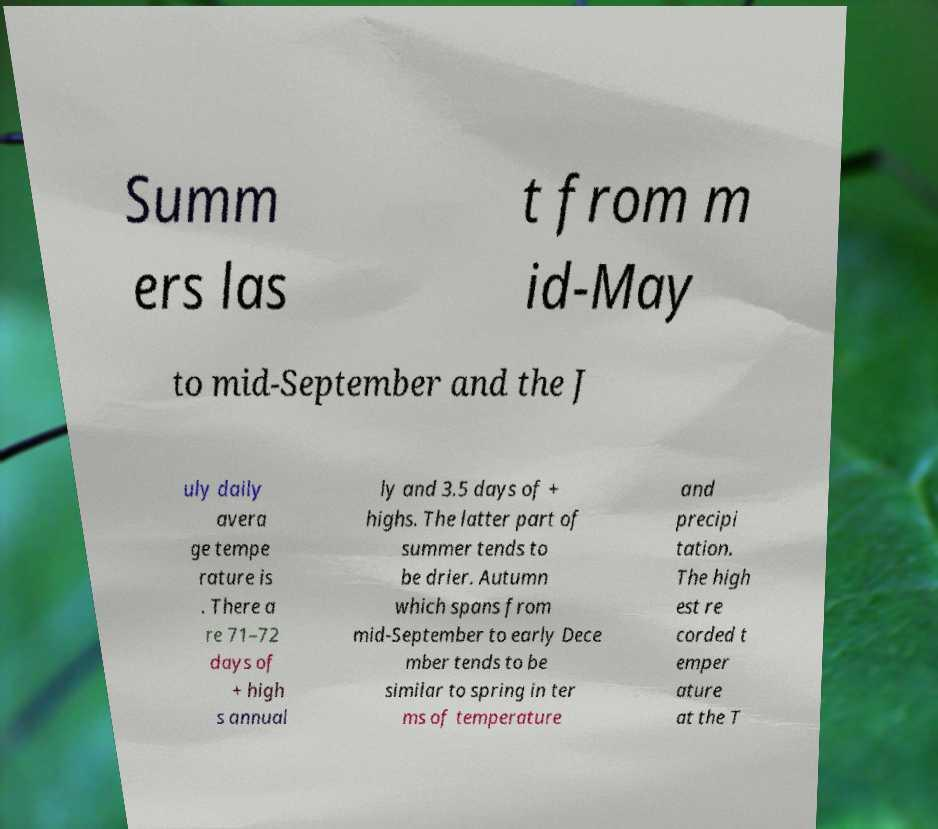I need the written content from this picture converted into text. Can you do that? Summ ers las t from m id-May to mid-September and the J uly daily avera ge tempe rature is . There a re 71–72 days of + high s annual ly and 3.5 days of + highs. The latter part of summer tends to be drier. Autumn which spans from mid-September to early Dece mber tends to be similar to spring in ter ms of temperature and precipi tation. The high est re corded t emper ature at the T 